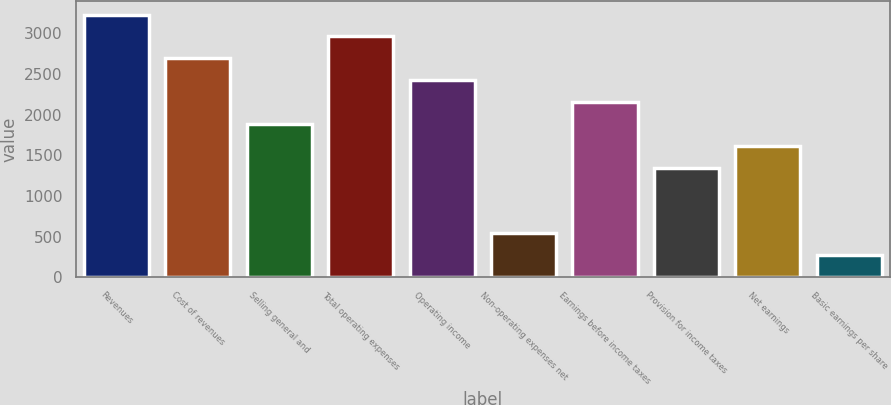Convert chart. <chart><loc_0><loc_0><loc_500><loc_500><bar_chart><fcel>Revenues<fcel>Cost of revenues<fcel>Selling general and<fcel>Total operating expenses<fcel>Operating income<fcel>Non-operating expenses net<fcel>Earnings before income taxes<fcel>Provision for income taxes<fcel>Net earnings<fcel>Basic earnings per share<nl><fcel>3232.6<fcel>2694.22<fcel>1886.65<fcel>2963.41<fcel>2425.03<fcel>540.7<fcel>2155.84<fcel>1348.27<fcel>1617.46<fcel>271.51<nl></chart> 